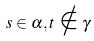Convert formula to latex. <formula><loc_0><loc_0><loc_500><loc_500>s \in \alpha , t \notin \gamma</formula> 